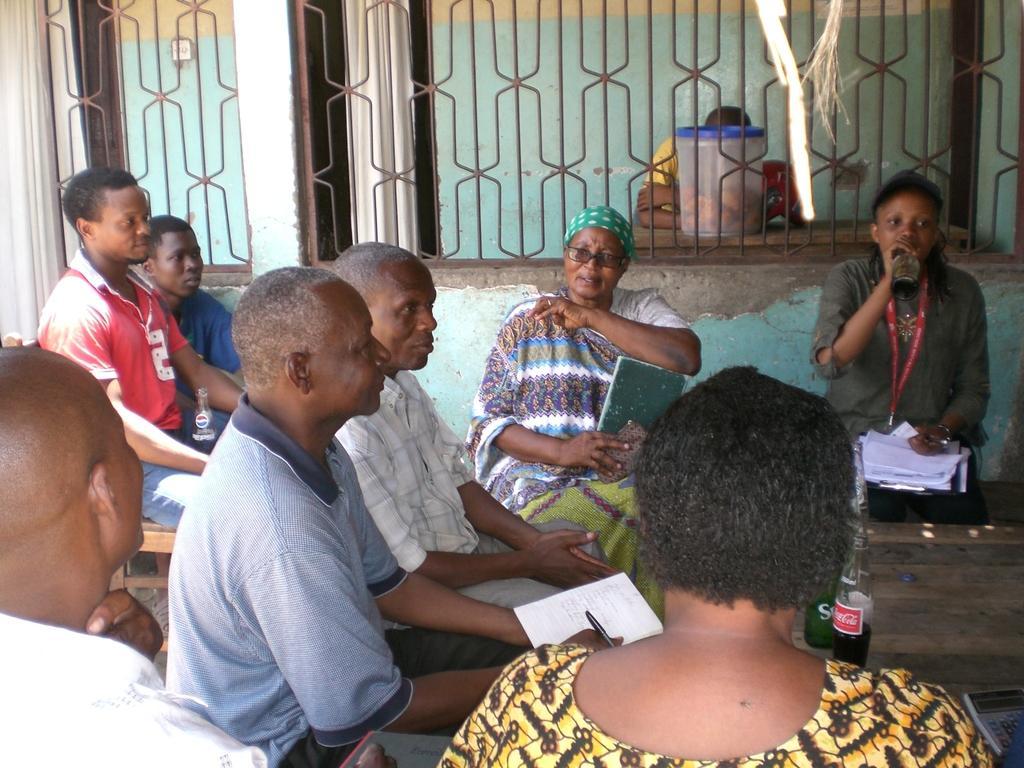Could you give a brief overview of what you see in this image? People are sitting. There are glass bottles. A person is holding a book. A person at the right is wearing an id card. Behind them there is a fencing and at the back there is a plastic box and a person is present. 